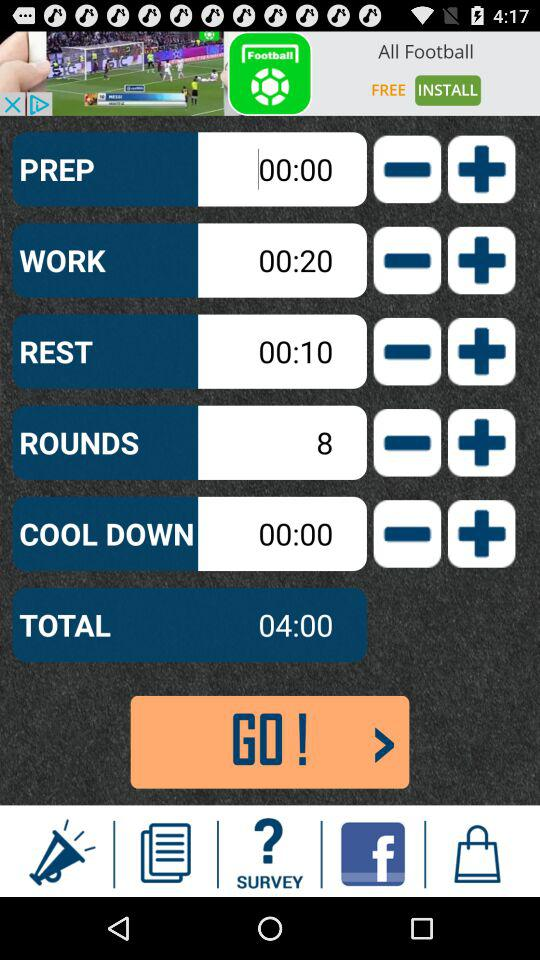How many rounds are there?
Answer the question using a single word or phrase. 8 